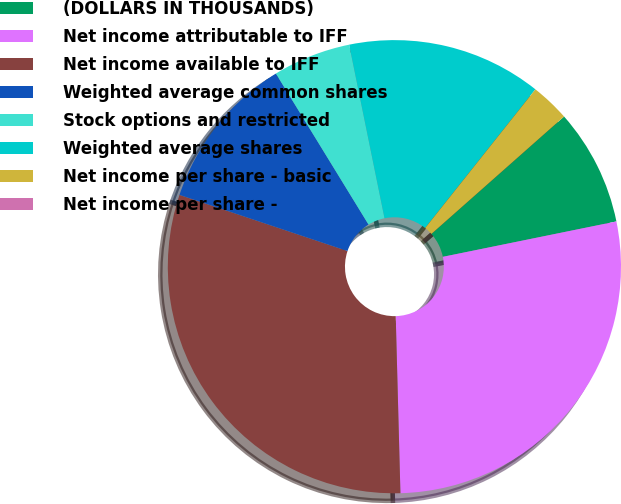Convert chart to OTSL. <chart><loc_0><loc_0><loc_500><loc_500><pie_chart><fcel>(DOLLARS IN THOUSANDS)<fcel>Net income attributable to IFF<fcel>Net income available to IFF<fcel>Weighted average common shares<fcel>Stock options and restricted<fcel>Weighted average shares<fcel>Net income per share - basic<fcel>Net income per share -<nl><fcel>8.33%<fcel>27.78%<fcel>30.56%<fcel>11.11%<fcel>5.56%<fcel>13.89%<fcel>2.78%<fcel>0.0%<nl></chart> 